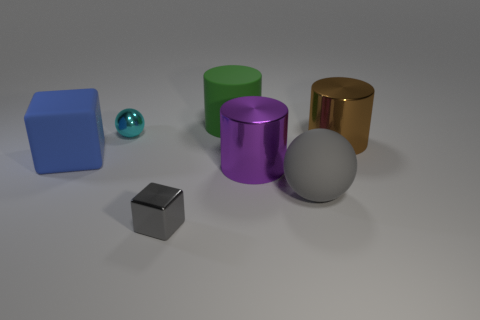Add 1 big matte cylinders. How many objects exist? 8 Subtract all balls. How many objects are left? 5 Add 3 purple cylinders. How many purple cylinders are left? 4 Add 5 large objects. How many large objects exist? 10 Subtract 0 cyan cubes. How many objects are left? 7 Subtract all small shiny objects. Subtract all large shiny things. How many objects are left? 3 